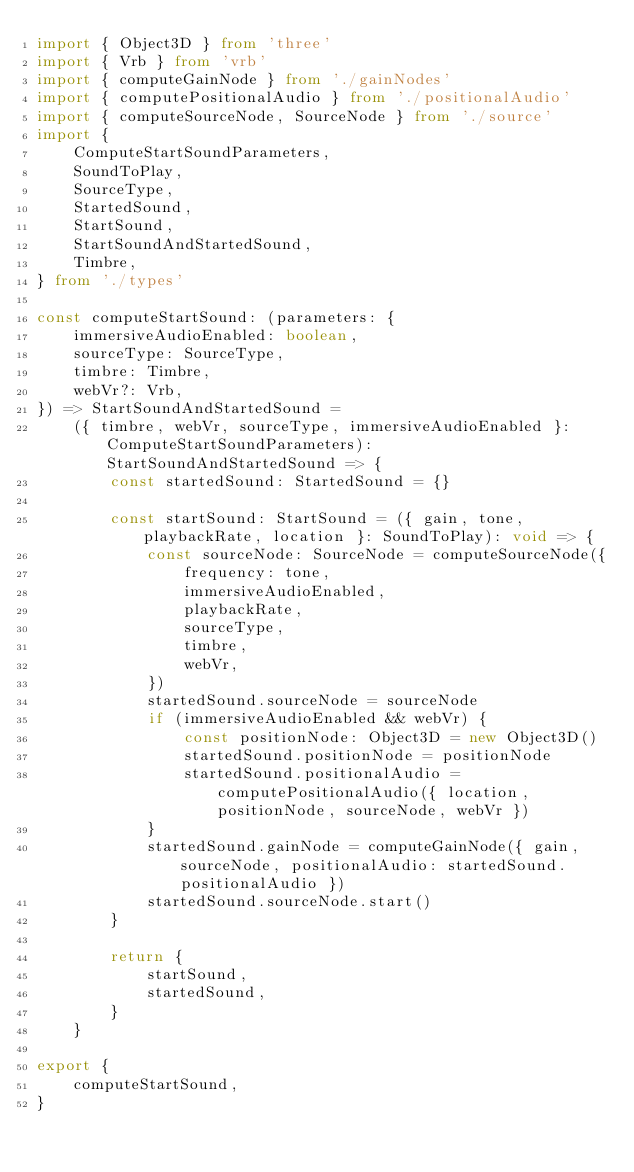<code> <loc_0><loc_0><loc_500><loc_500><_TypeScript_>import { Object3D } from 'three'
import { Vrb } from 'vrb'
import { computeGainNode } from './gainNodes'
import { computePositionalAudio } from './positionalAudio'
import { computeSourceNode, SourceNode } from './source'
import {
    ComputeStartSoundParameters,
    SoundToPlay,
    SourceType,
    StartedSound,
    StartSound,
    StartSoundAndStartedSound,
    Timbre,
} from './types'

const computeStartSound: (parameters: {
    immersiveAudioEnabled: boolean,
    sourceType: SourceType,
    timbre: Timbre,
    webVr?: Vrb,
}) => StartSoundAndStartedSound =
    ({ timbre, webVr, sourceType, immersiveAudioEnabled }: ComputeStartSoundParameters): StartSoundAndStartedSound => {
        const startedSound: StartedSound = {}

        const startSound: StartSound = ({ gain, tone, playbackRate, location }: SoundToPlay): void => {
            const sourceNode: SourceNode = computeSourceNode({
                frequency: tone,
                immersiveAudioEnabled,
                playbackRate,
                sourceType,
                timbre,
                webVr,
            })
            startedSound.sourceNode = sourceNode
            if (immersiveAudioEnabled && webVr) {
                const positionNode: Object3D = new Object3D()
                startedSound.positionNode = positionNode
                startedSound.positionalAudio = computePositionalAudio({ location, positionNode, sourceNode, webVr })
            }
            startedSound.gainNode = computeGainNode({ gain, sourceNode, positionalAudio: startedSound.positionalAudio })
            startedSound.sourceNode.start()
        }

        return {
            startSound,
            startedSound,
        }
    }

export {
    computeStartSound,
}
</code> 